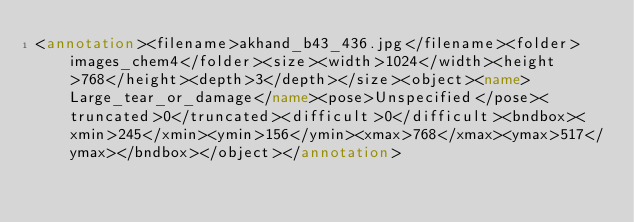Convert code to text. <code><loc_0><loc_0><loc_500><loc_500><_XML_><annotation><filename>akhand_b43_436.jpg</filename><folder>images_chem4</folder><size><width>1024</width><height>768</height><depth>3</depth></size><object><name>Large_tear_or_damage</name><pose>Unspecified</pose><truncated>0</truncated><difficult>0</difficult><bndbox><xmin>245</xmin><ymin>156</ymin><xmax>768</xmax><ymax>517</ymax></bndbox></object></annotation></code> 